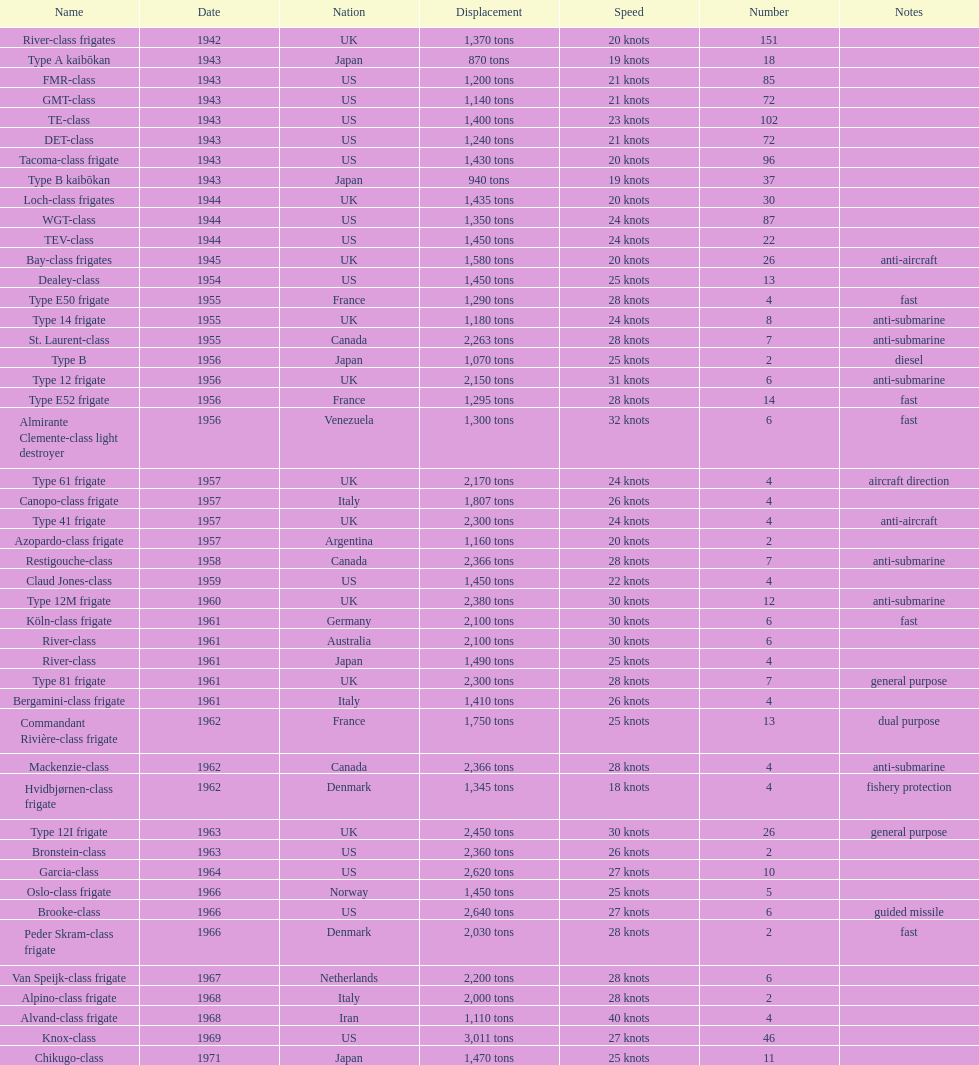Which name has the largest displacement? Knox-class. 